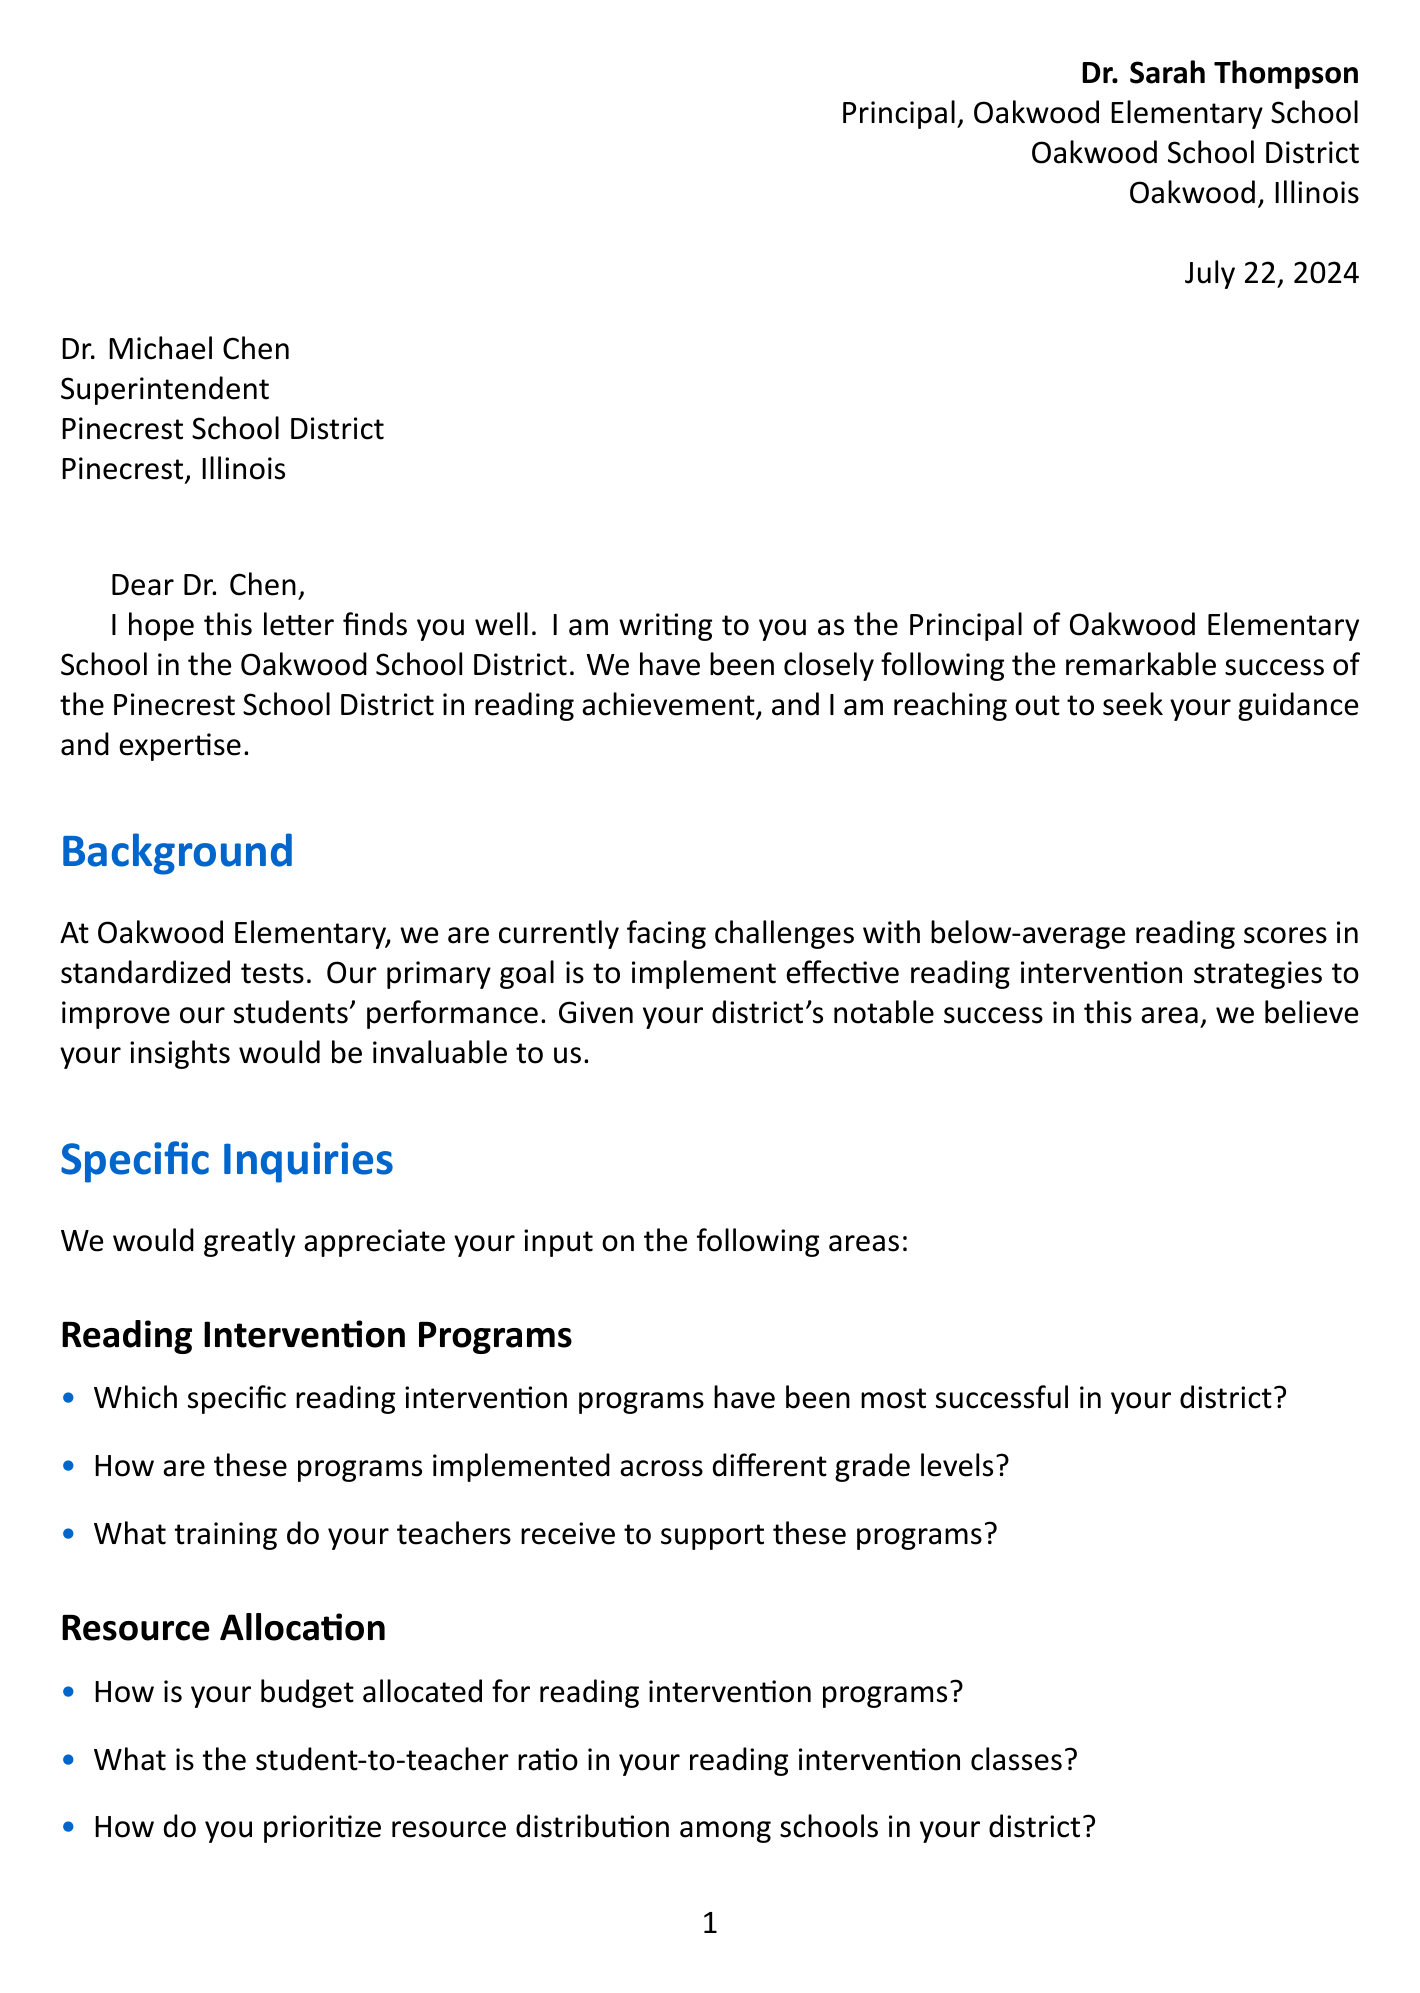What is the name of the sender? The sender's name is found in the closing of the letter, specifically listed as Dr. Sarah Thompson.
Answer: Dr. Sarah Thompson What is the recipient's title? The recipient's title is specifically stated in the opening of the letter addressed to Dr. Michael Chen.
Answer: Superintendent What is the objective mentioned in the letter? The objective is included in the background section, describing the main goal of the inquiry.
Answer: Improve student performance Which reading intervention program is published by Houghton Mifflin Harcourt? This program is named in the successful programs section of the letter.
Answer: Read 180 What is the phone number provided for contact? The phone number is clearly outlined in the closing remarks for Dr. Sarah Thompson.
Answer: (555) 123-4567 How many specific inquiries are listed in the document? The total specific inquiries can be counted from the various topics presented in the letter.
Answer: Four What assessment tools are mentioned for identifying students in need? The question about assessment tools is included under the assessment and progress monitoring section.
Answer: Not specified in the document What is the current situation faced by Oakwood Elementary School? The current situation is detailed in the background section to explain Elmwood's challenges.
Answer: Below-average reading scores How does the letter close? The closing remarks summarize the letter and express gratitude, which also outlines interest in collaboration.
Answer: Sincerely 